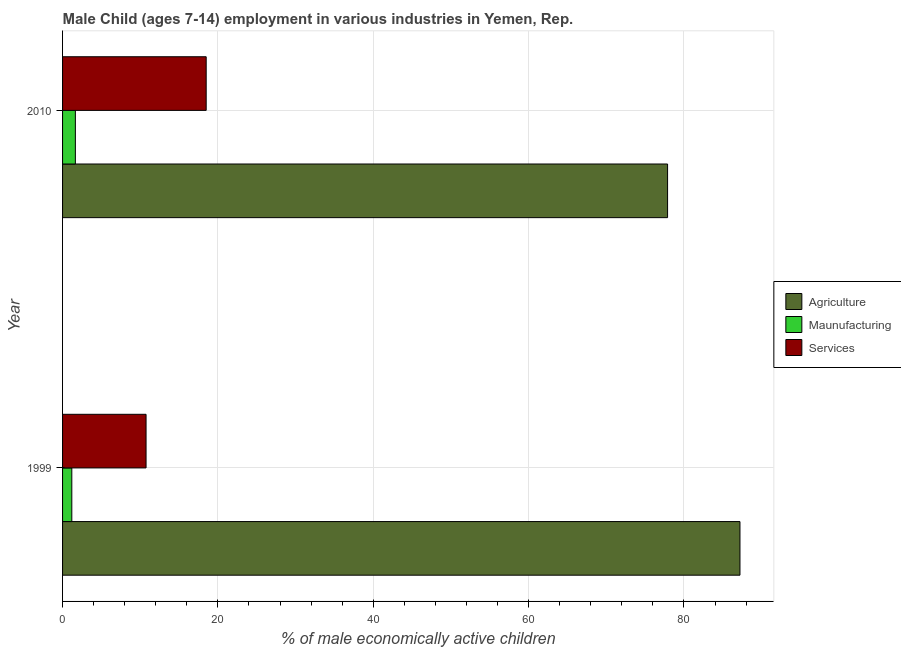How many different coloured bars are there?
Provide a succinct answer. 3. How many bars are there on the 2nd tick from the top?
Offer a very short reply. 3. How many bars are there on the 2nd tick from the bottom?
Provide a short and direct response. 3. In how many cases, is the number of bars for a given year not equal to the number of legend labels?
Ensure brevity in your answer.  0. What is the percentage of economically active children in agriculture in 1999?
Provide a succinct answer. 87.21. Across all years, what is the maximum percentage of economically active children in manufacturing?
Provide a succinct answer. 1.65. Across all years, what is the minimum percentage of economically active children in manufacturing?
Keep it short and to the point. 1.19. What is the total percentage of economically active children in manufacturing in the graph?
Your response must be concise. 2.84. What is the difference between the percentage of economically active children in manufacturing in 1999 and that in 2010?
Make the answer very short. -0.46. What is the difference between the percentage of economically active children in agriculture in 2010 and the percentage of economically active children in services in 1999?
Your answer should be compact. 67.14. What is the average percentage of economically active children in manufacturing per year?
Your answer should be very brief. 1.42. In the year 2010, what is the difference between the percentage of economically active children in services and percentage of economically active children in manufacturing?
Keep it short and to the point. 16.84. In how many years, is the percentage of economically active children in agriculture greater than 44 %?
Your response must be concise. 2. What is the ratio of the percentage of economically active children in services in 1999 to that in 2010?
Offer a terse response. 0.58. What does the 1st bar from the top in 2010 represents?
Your answer should be very brief. Services. What does the 1st bar from the bottom in 1999 represents?
Provide a short and direct response. Agriculture. How many years are there in the graph?
Ensure brevity in your answer.  2. What is the difference between two consecutive major ticks on the X-axis?
Ensure brevity in your answer.  20. Are the values on the major ticks of X-axis written in scientific E-notation?
Offer a very short reply. No. Does the graph contain grids?
Offer a terse response. Yes. How many legend labels are there?
Your answer should be compact. 3. How are the legend labels stacked?
Your answer should be compact. Vertical. What is the title of the graph?
Your answer should be very brief. Male Child (ages 7-14) employment in various industries in Yemen, Rep. Does "Self-employed" appear as one of the legend labels in the graph?
Ensure brevity in your answer.  No. What is the label or title of the X-axis?
Keep it short and to the point. % of male economically active children. What is the % of male economically active children in Agriculture in 1999?
Your answer should be very brief. 87.21. What is the % of male economically active children of Maunufacturing in 1999?
Ensure brevity in your answer.  1.19. What is the % of male economically active children in Services in 1999?
Your answer should be very brief. 10.75. What is the % of male economically active children in Agriculture in 2010?
Provide a succinct answer. 77.89. What is the % of male economically active children in Maunufacturing in 2010?
Provide a succinct answer. 1.65. What is the % of male economically active children of Services in 2010?
Ensure brevity in your answer.  18.49. Across all years, what is the maximum % of male economically active children in Agriculture?
Your answer should be very brief. 87.21. Across all years, what is the maximum % of male economically active children of Maunufacturing?
Keep it short and to the point. 1.65. Across all years, what is the maximum % of male economically active children in Services?
Give a very brief answer. 18.49. Across all years, what is the minimum % of male economically active children in Agriculture?
Give a very brief answer. 77.89. Across all years, what is the minimum % of male economically active children of Maunufacturing?
Your answer should be compact. 1.19. Across all years, what is the minimum % of male economically active children in Services?
Offer a terse response. 10.75. What is the total % of male economically active children in Agriculture in the graph?
Your answer should be compact. 165.1. What is the total % of male economically active children of Maunufacturing in the graph?
Your answer should be very brief. 2.84. What is the total % of male economically active children of Services in the graph?
Offer a very short reply. 29.24. What is the difference between the % of male economically active children in Agriculture in 1999 and that in 2010?
Provide a short and direct response. 9.32. What is the difference between the % of male economically active children of Maunufacturing in 1999 and that in 2010?
Make the answer very short. -0.46. What is the difference between the % of male economically active children in Services in 1999 and that in 2010?
Give a very brief answer. -7.74. What is the difference between the % of male economically active children of Agriculture in 1999 and the % of male economically active children of Maunufacturing in 2010?
Your answer should be compact. 85.56. What is the difference between the % of male economically active children of Agriculture in 1999 and the % of male economically active children of Services in 2010?
Offer a very short reply. 68.72. What is the difference between the % of male economically active children of Maunufacturing in 1999 and the % of male economically active children of Services in 2010?
Offer a terse response. -17.3. What is the average % of male economically active children in Agriculture per year?
Provide a short and direct response. 82.55. What is the average % of male economically active children in Maunufacturing per year?
Your answer should be very brief. 1.42. What is the average % of male economically active children in Services per year?
Your answer should be compact. 14.62. In the year 1999, what is the difference between the % of male economically active children of Agriculture and % of male economically active children of Maunufacturing?
Keep it short and to the point. 86.02. In the year 1999, what is the difference between the % of male economically active children of Agriculture and % of male economically active children of Services?
Your answer should be very brief. 76.46. In the year 1999, what is the difference between the % of male economically active children in Maunufacturing and % of male economically active children in Services?
Make the answer very short. -9.56. In the year 2010, what is the difference between the % of male economically active children in Agriculture and % of male economically active children in Maunufacturing?
Keep it short and to the point. 76.24. In the year 2010, what is the difference between the % of male economically active children in Agriculture and % of male economically active children in Services?
Offer a very short reply. 59.4. In the year 2010, what is the difference between the % of male economically active children in Maunufacturing and % of male economically active children in Services?
Provide a short and direct response. -16.84. What is the ratio of the % of male economically active children in Agriculture in 1999 to that in 2010?
Provide a succinct answer. 1.12. What is the ratio of the % of male economically active children of Maunufacturing in 1999 to that in 2010?
Offer a very short reply. 0.72. What is the ratio of the % of male economically active children of Services in 1999 to that in 2010?
Make the answer very short. 0.58. What is the difference between the highest and the second highest % of male economically active children of Agriculture?
Offer a very short reply. 9.32. What is the difference between the highest and the second highest % of male economically active children in Maunufacturing?
Offer a very short reply. 0.46. What is the difference between the highest and the second highest % of male economically active children in Services?
Provide a short and direct response. 7.74. What is the difference between the highest and the lowest % of male economically active children in Agriculture?
Your answer should be very brief. 9.32. What is the difference between the highest and the lowest % of male economically active children in Maunufacturing?
Ensure brevity in your answer.  0.46. What is the difference between the highest and the lowest % of male economically active children in Services?
Offer a terse response. 7.74. 